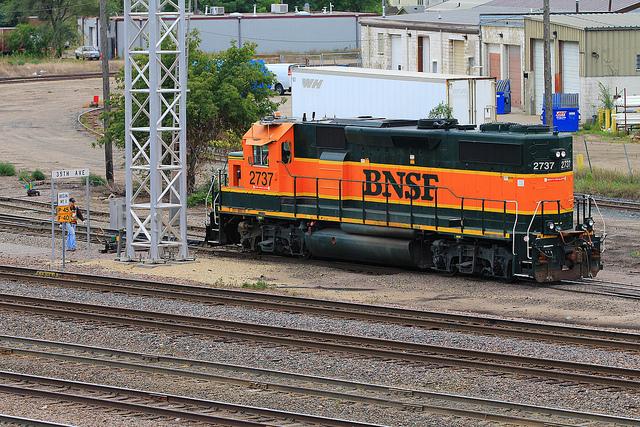What is the bright orange object?
Keep it brief. Train. Is the train engine orange and black?
Answer briefly. Yes. What design is on the side of the train?
Give a very brief answer. Bnsf. Who is the man standing beside the train?
Keep it brief. Worker. What are the numbers on the train?
Answer briefly. 2737. 